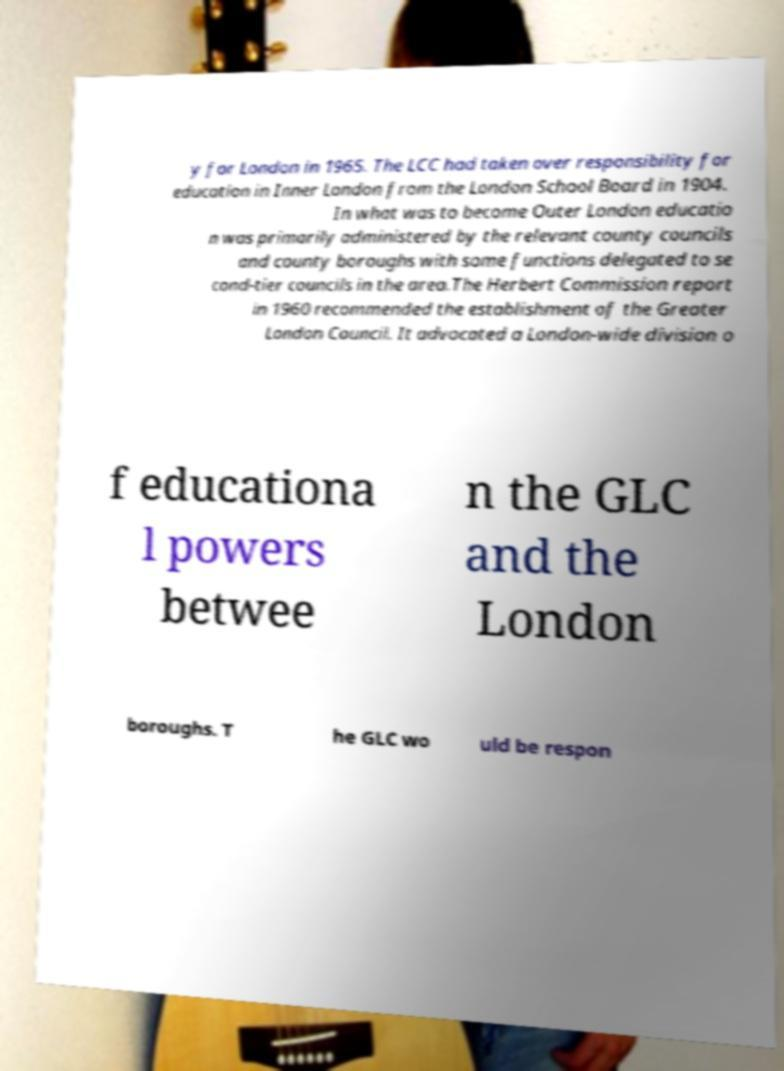Please read and relay the text visible in this image. What does it say? y for London in 1965. The LCC had taken over responsibility for education in Inner London from the London School Board in 1904. In what was to become Outer London educatio n was primarily administered by the relevant county councils and county boroughs with some functions delegated to se cond-tier councils in the area.The Herbert Commission report in 1960 recommended the establishment of the Greater London Council. It advocated a London-wide division o f educationa l powers betwee n the GLC and the London boroughs. T he GLC wo uld be respon 